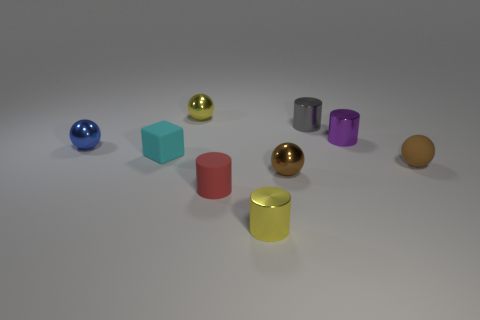Does the small matte object that is on the right side of the tiny purple cylinder have the same color as the tiny shiny ball behind the tiny blue metal ball?
Your response must be concise. No. What number of other things are the same size as the gray cylinder?
Provide a short and direct response. 8. Are there any red matte cylinders on the right side of the small gray cylinder to the right of the object in front of the rubber cylinder?
Your response must be concise. No. Does the tiny yellow object behind the cyan block have the same material as the purple cylinder?
Your answer should be compact. Yes. What is the color of the other tiny matte object that is the same shape as the blue object?
Keep it short and to the point. Brown. Is there any other thing that is the same shape as the small brown rubber object?
Provide a short and direct response. Yes. Is the number of tiny red rubber things behind the small cyan object the same as the number of big brown matte objects?
Your response must be concise. Yes. There is a brown metallic object; are there any purple cylinders left of it?
Your answer should be compact. No. There is a yellow thing that is in front of the shiny ball that is to the right of the small yellow thing that is in front of the blue metal thing; what size is it?
Make the answer very short. Small. Is the shape of the object behind the small gray cylinder the same as the small brown object in front of the rubber ball?
Keep it short and to the point. Yes. 